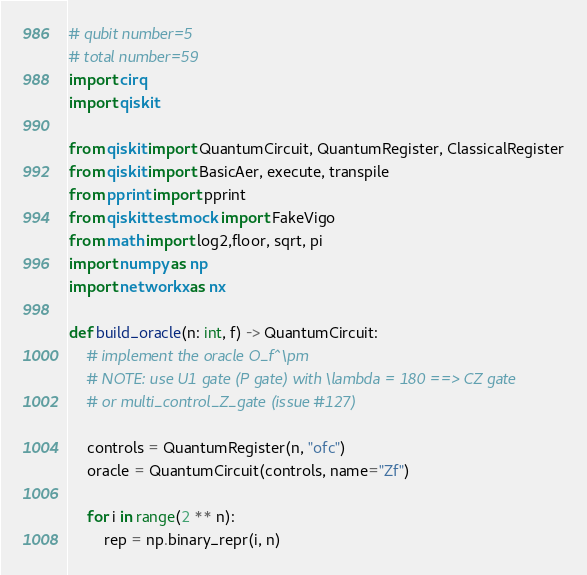<code> <loc_0><loc_0><loc_500><loc_500><_Python_># qubit number=5
# total number=59
import cirq
import qiskit

from qiskit import QuantumCircuit, QuantumRegister, ClassicalRegister
from qiskit import BasicAer, execute, transpile
from pprint import pprint
from qiskit.test.mock import FakeVigo
from math import log2,floor, sqrt, pi
import numpy as np
import networkx as nx

def build_oracle(n: int, f) -> QuantumCircuit:
    # implement the oracle O_f^\pm
    # NOTE: use U1 gate (P gate) with \lambda = 180 ==> CZ gate
    # or multi_control_Z_gate (issue #127)

    controls = QuantumRegister(n, "ofc")
    oracle = QuantumCircuit(controls, name="Zf")

    for i in range(2 ** n):
        rep = np.binary_repr(i, n)</code> 